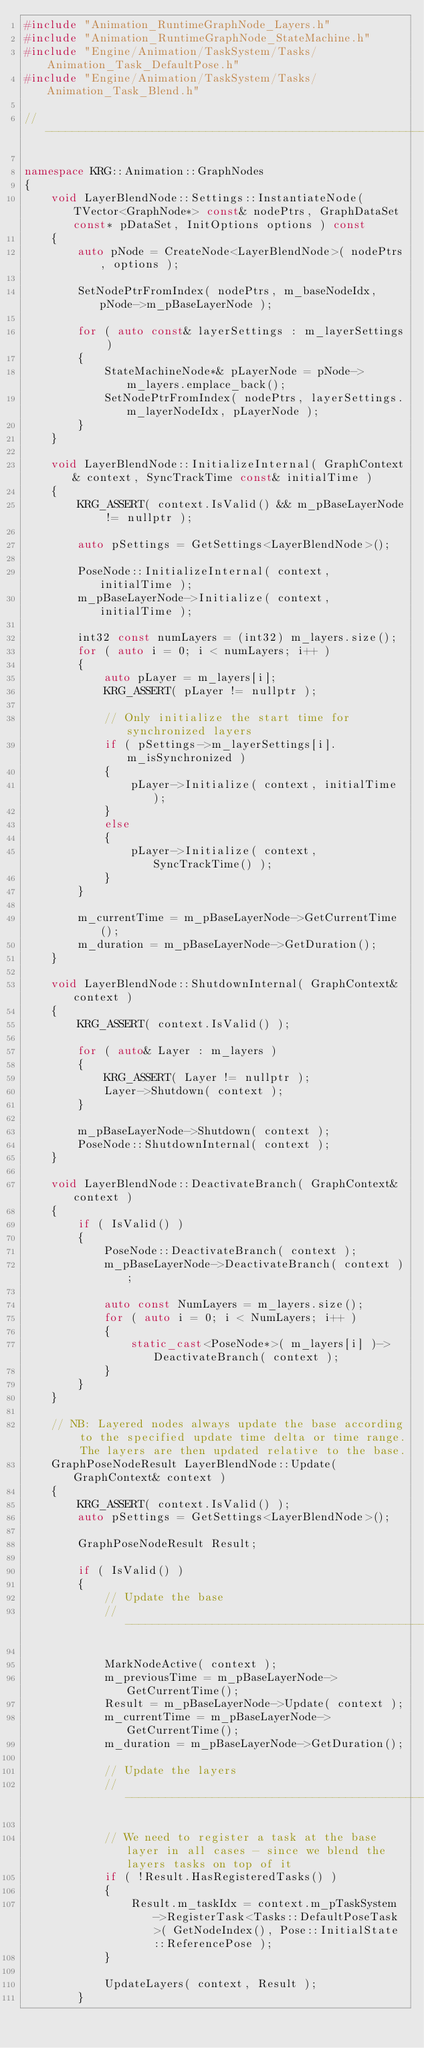<code> <loc_0><loc_0><loc_500><loc_500><_C++_>#include "Animation_RuntimeGraphNode_Layers.h"
#include "Animation_RuntimeGraphNode_StateMachine.h"
#include "Engine/Animation/TaskSystem/Tasks/Animation_Task_DefaultPose.h"
#include "Engine/Animation/TaskSystem/Tasks/Animation_Task_Blend.h"

//-------------------------------------------------------------------------

namespace KRG::Animation::GraphNodes
{
    void LayerBlendNode::Settings::InstantiateNode( TVector<GraphNode*> const& nodePtrs, GraphDataSet const* pDataSet, InitOptions options ) const
    {
        auto pNode = CreateNode<LayerBlendNode>( nodePtrs, options );

        SetNodePtrFromIndex( nodePtrs, m_baseNodeIdx, pNode->m_pBaseLayerNode );

        for ( auto const& layerSettings : m_layerSettings )
        {
            StateMachineNode*& pLayerNode = pNode->m_layers.emplace_back();
            SetNodePtrFromIndex( nodePtrs, layerSettings.m_layerNodeIdx, pLayerNode );
        }
    }

    void LayerBlendNode::InitializeInternal( GraphContext& context, SyncTrackTime const& initialTime )
    {
        KRG_ASSERT( context.IsValid() && m_pBaseLayerNode != nullptr );

        auto pSettings = GetSettings<LayerBlendNode>();

        PoseNode::InitializeInternal( context, initialTime );
        m_pBaseLayerNode->Initialize( context, initialTime );

        int32 const numLayers = (int32) m_layers.size();
        for ( auto i = 0; i < numLayers; i++ )
        {
            auto pLayer = m_layers[i];
            KRG_ASSERT( pLayer != nullptr );

            // Only initialize the start time for synchronized layers
            if ( pSettings->m_layerSettings[i].m_isSynchronized )
            {
                pLayer->Initialize( context, initialTime );
            }
            else
            {
                pLayer->Initialize( context, SyncTrackTime() );
            }
        }

        m_currentTime = m_pBaseLayerNode->GetCurrentTime();
        m_duration = m_pBaseLayerNode->GetDuration();
    }

    void LayerBlendNode::ShutdownInternal( GraphContext& context )
    {
        KRG_ASSERT( context.IsValid() );

        for ( auto& Layer : m_layers )
        {
            KRG_ASSERT( Layer != nullptr );
            Layer->Shutdown( context );
        }

        m_pBaseLayerNode->Shutdown( context );
        PoseNode::ShutdownInternal( context );
    }

    void LayerBlendNode::DeactivateBranch( GraphContext& context )
    {
        if ( IsValid() )
        {
            PoseNode::DeactivateBranch( context );
            m_pBaseLayerNode->DeactivateBranch( context );

            auto const NumLayers = m_layers.size();
            for ( auto i = 0; i < NumLayers; i++ )
            {
                static_cast<PoseNode*>( m_layers[i] )->DeactivateBranch( context );
            }
        }
    }

    // NB: Layered nodes always update the base according to the specified update time delta or time range. The layers are then updated relative to the base.
    GraphPoseNodeResult LayerBlendNode::Update( GraphContext& context )
    {
        KRG_ASSERT( context.IsValid() );
        auto pSettings = GetSettings<LayerBlendNode>();

        GraphPoseNodeResult Result;

        if ( IsValid() )
        {
            // Update the base
            //-------------------------------------------------------------------------

            MarkNodeActive( context );
            m_previousTime = m_pBaseLayerNode->GetCurrentTime();
            Result = m_pBaseLayerNode->Update( context );
            m_currentTime = m_pBaseLayerNode->GetCurrentTime();
            m_duration = m_pBaseLayerNode->GetDuration();

            // Update the layers
            //-------------------------------------------------------------------------

            // We need to register a task at the base layer in all cases - since we blend the layers tasks on top of it
            if ( !Result.HasRegisteredTasks() )
            {
                Result.m_taskIdx = context.m_pTaskSystem->RegisterTask<Tasks::DefaultPoseTask>( GetNodeIndex(), Pose::InitialState::ReferencePose );
            }

            UpdateLayers( context, Result );
        }
</code> 